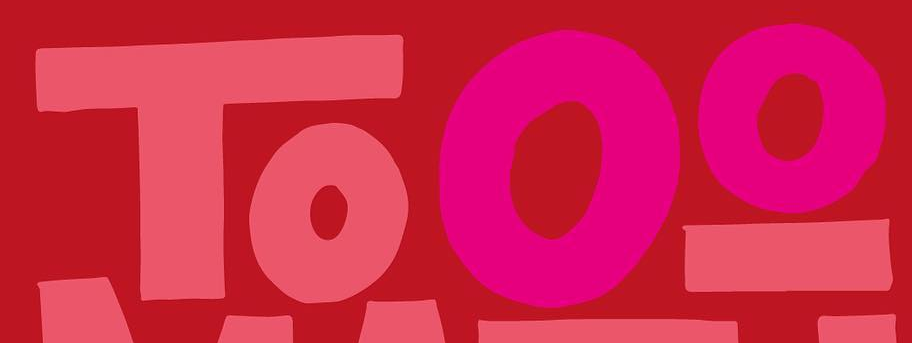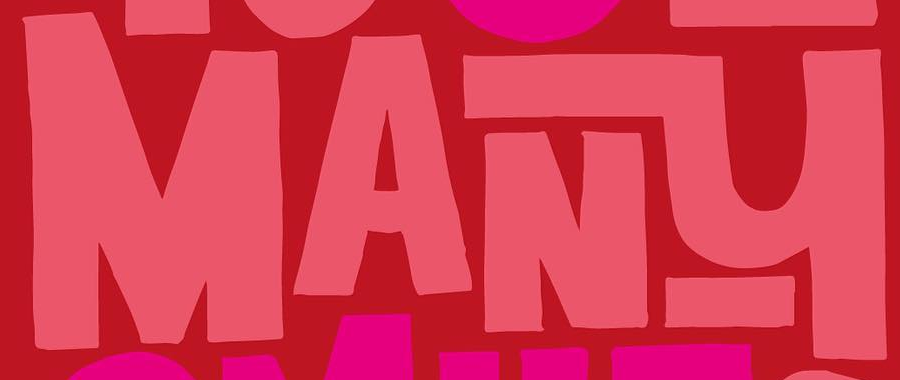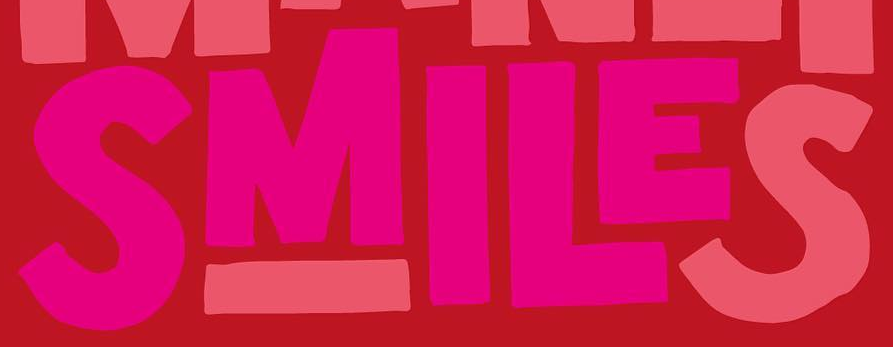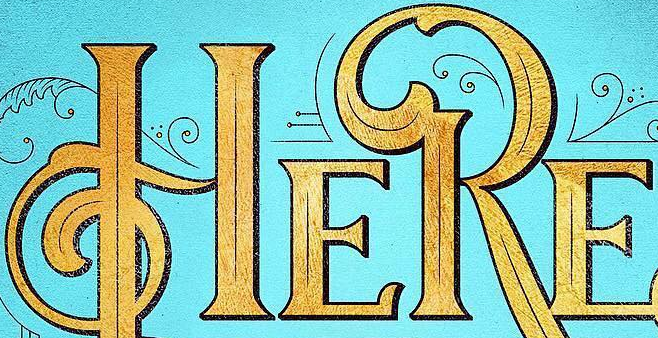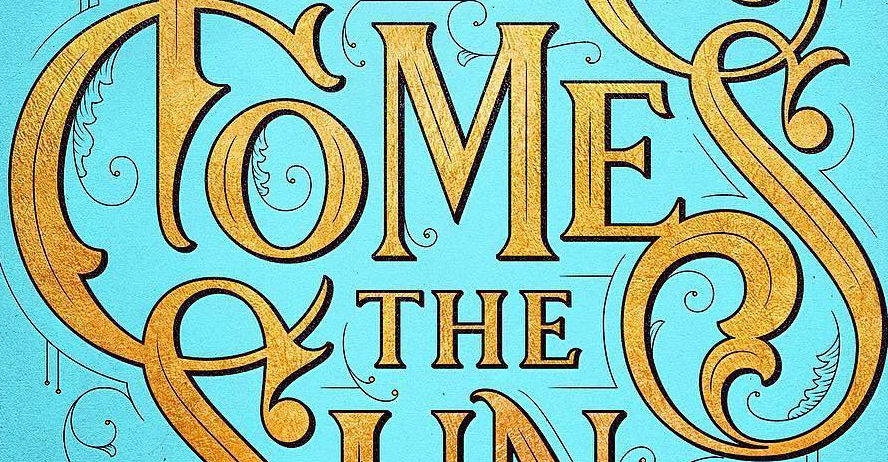What text appears in these images from left to right, separated by a semicolon? Tooo; MANY; SMILES; HERE; COMES 